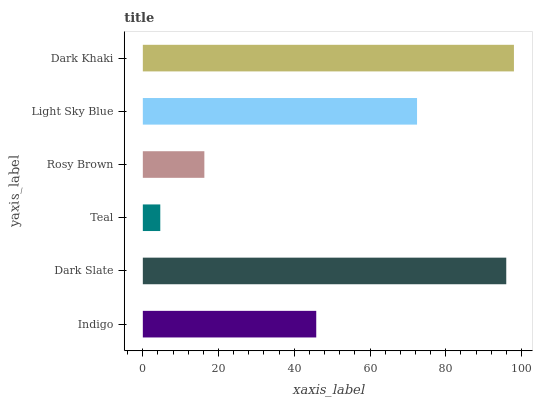Is Teal the minimum?
Answer yes or no. Yes. Is Dark Khaki the maximum?
Answer yes or no. Yes. Is Dark Slate the minimum?
Answer yes or no. No. Is Dark Slate the maximum?
Answer yes or no. No. Is Dark Slate greater than Indigo?
Answer yes or no. Yes. Is Indigo less than Dark Slate?
Answer yes or no. Yes. Is Indigo greater than Dark Slate?
Answer yes or no. No. Is Dark Slate less than Indigo?
Answer yes or no. No. Is Light Sky Blue the high median?
Answer yes or no. Yes. Is Indigo the low median?
Answer yes or no. Yes. Is Dark Khaki the high median?
Answer yes or no. No. Is Teal the low median?
Answer yes or no. No. 